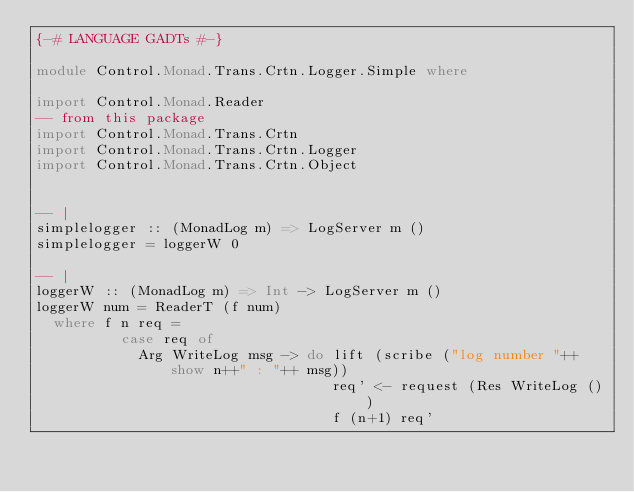<code> <loc_0><loc_0><loc_500><loc_500><_Haskell_>{-# LANGUAGE GADTs #-}

module Control.Monad.Trans.Crtn.Logger.Simple where

import Control.Monad.Reader 
-- from this package
import Control.Monad.Trans.Crtn
import Control.Monad.Trans.Crtn.Logger 
import Control.Monad.Trans.Crtn.Object


-- | 
simplelogger :: (MonadLog m) => LogServer m () 
simplelogger = loggerW 0
 
-- |
loggerW :: (MonadLog m) => Int -> LogServer m () 
loggerW num = ReaderT (f num)
  where f n req = 
          case req of 
            Arg WriteLog msg -> do lift (scribe ("log number "++show n++" : "++ msg))
                                   req' <- request (Res WriteLog ())
                                   f (n+1) req' 

</code> 